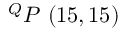<formula> <loc_0><loc_0><loc_500><loc_500>^ { Q } P \ ( 1 5 , 1 5 )</formula> 